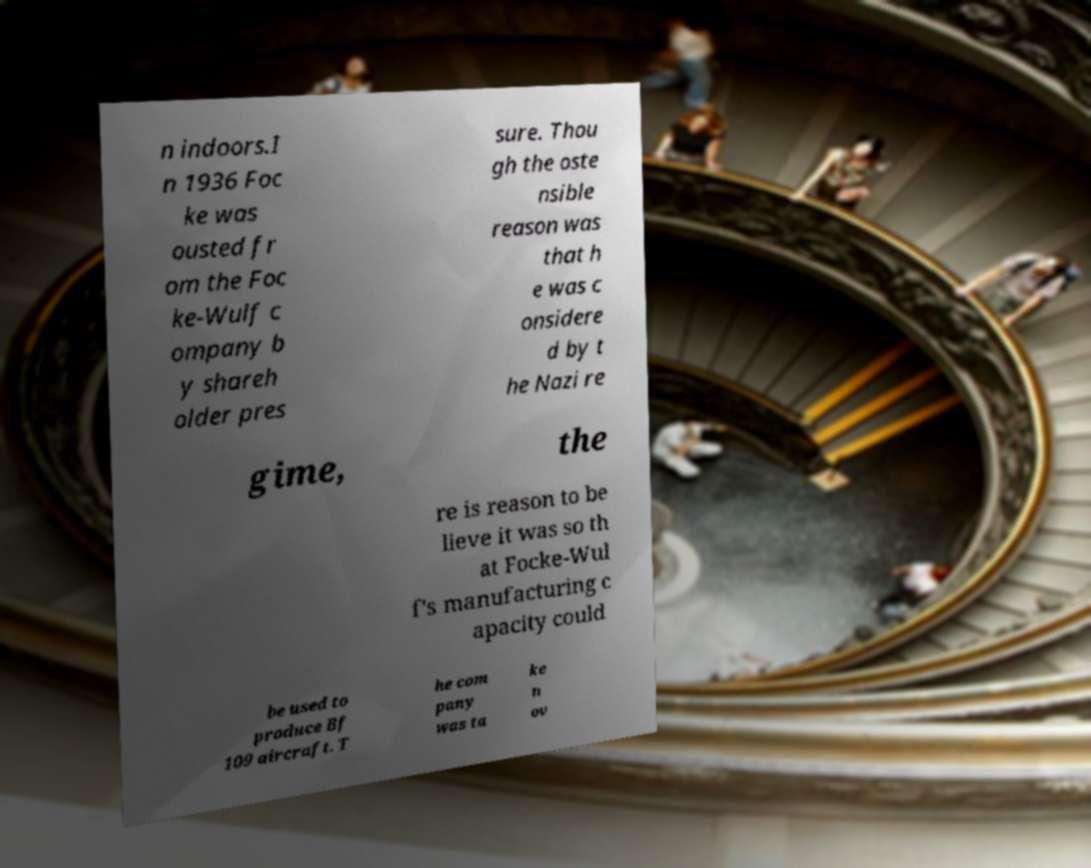Could you extract and type out the text from this image? n indoors.I n 1936 Foc ke was ousted fr om the Foc ke-Wulf c ompany b y shareh older pres sure. Thou gh the oste nsible reason was that h e was c onsidere d by t he Nazi re gime, the re is reason to be lieve it was so th at Focke-Wul f's manufacturing c apacity could be used to produce Bf 109 aircraft. T he com pany was ta ke n ov 